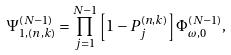<formula> <loc_0><loc_0><loc_500><loc_500>\Psi _ { 1 , ( n , k ) } ^ { ( N - 1 ) } = \prod _ { j = 1 } ^ { N - 1 } \left [ 1 - P _ { j } ^ { ( n , k ) } \right ] \Phi _ { \omega , 0 } ^ { ( N - 1 ) } ,</formula> 